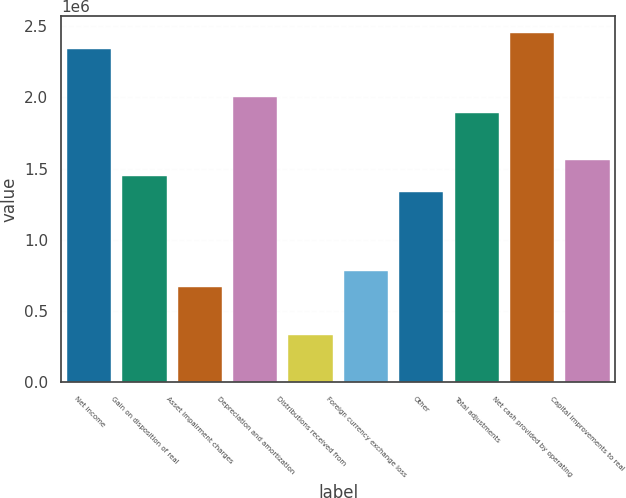Convert chart to OTSL. <chart><loc_0><loc_0><loc_500><loc_500><bar_chart><fcel>Net income<fcel>Gain on disposition of real<fcel>Asset impairment charges<fcel>Depreciation and amortization<fcel>Distributions received from<fcel>Foreign currency exchange loss<fcel>Other<fcel>Total adjustments<fcel>Net cash provided by operating<fcel>Capital improvements to real<nl><fcel>2.33695e+06<fcel>1.4467e+06<fcel>667731<fcel>2.00311e+06<fcel>333886<fcel>779012<fcel>1.33542e+06<fcel>1.89183e+06<fcel>2.44824e+06<fcel>1.55798e+06<nl></chart> 